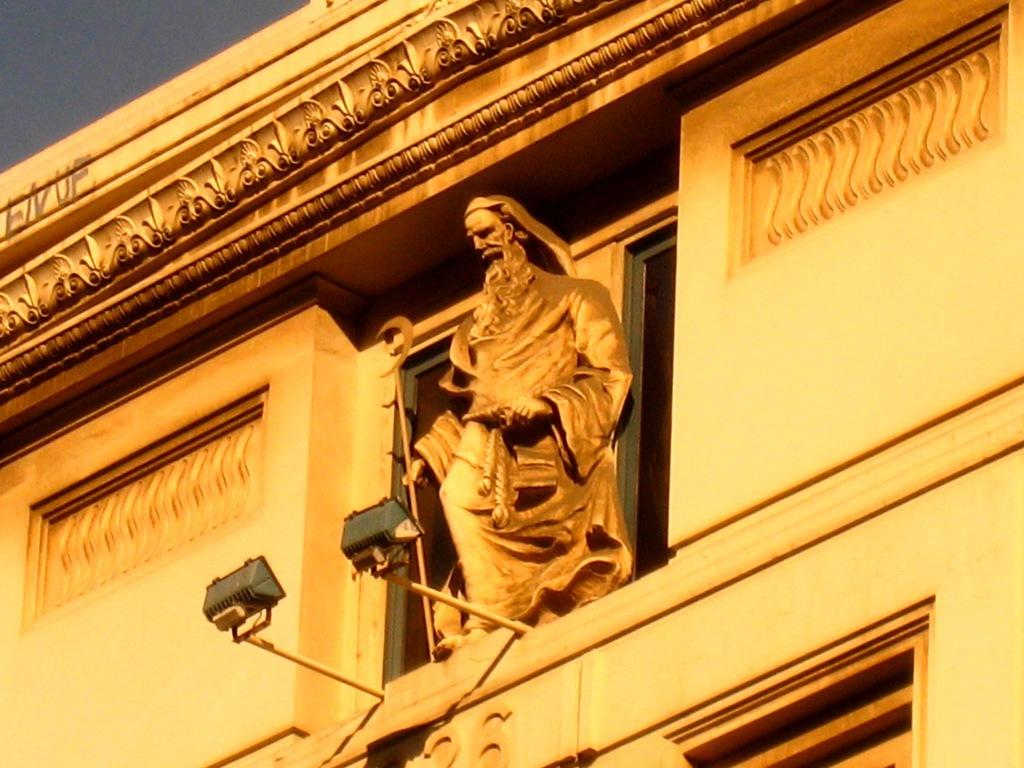What is the main subject in the center of the image? There is a statue in the center of the image. Where is the statue located? The statue is on the window of a building. What is present in front of the statue? There are lights in front of the statue. What other structure can be seen in the image? There is a building in the image. What unit of measurement is used to determine the size of the beam in the image? There is no beam present in the image, so it is not possible to determine the unit of measurement used for its size. 